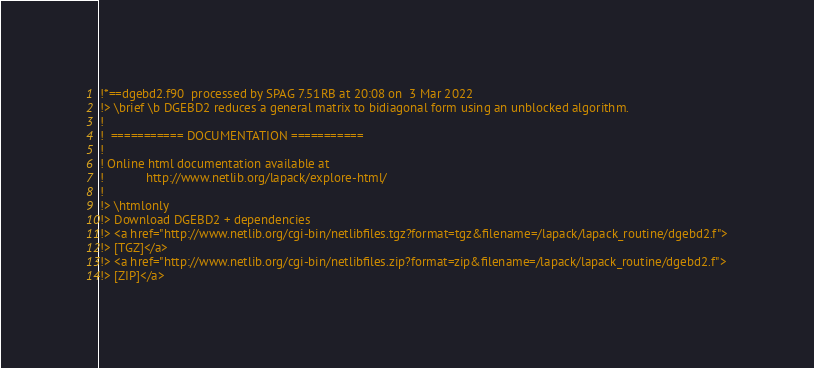<code> <loc_0><loc_0><loc_500><loc_500><_FORTRAN_>!*==dgebd2.f90  processed by SPAG 7.51RB at 20:08 on  3 Mar 2022
!> \brief \b DGEBD2 reduces a general matrix to bidiagonal form using an unblocked algorithm.
!
!  =========== DOCUMENTATION ===========
!
! Online html documentation available at
!            http://www.netlib.org/lapack/explore-html/
!
!> \htmlonly
!> Download DGEBD2 + dependencies
!> <a href="http://www.netlib.org/cgi-bin/netlibfiles.tgz?format=tgz&filename=/lapack/lapack_routine/dgebd2.f">
!> [TGZ]</a>
!> <a href="http://www.netlib.org/cgi-bin/netlibfiles.zip?format=zip&filename=/lapack/lapack_routine/dgebd2.f">
!> [ZIP]</a></code> 